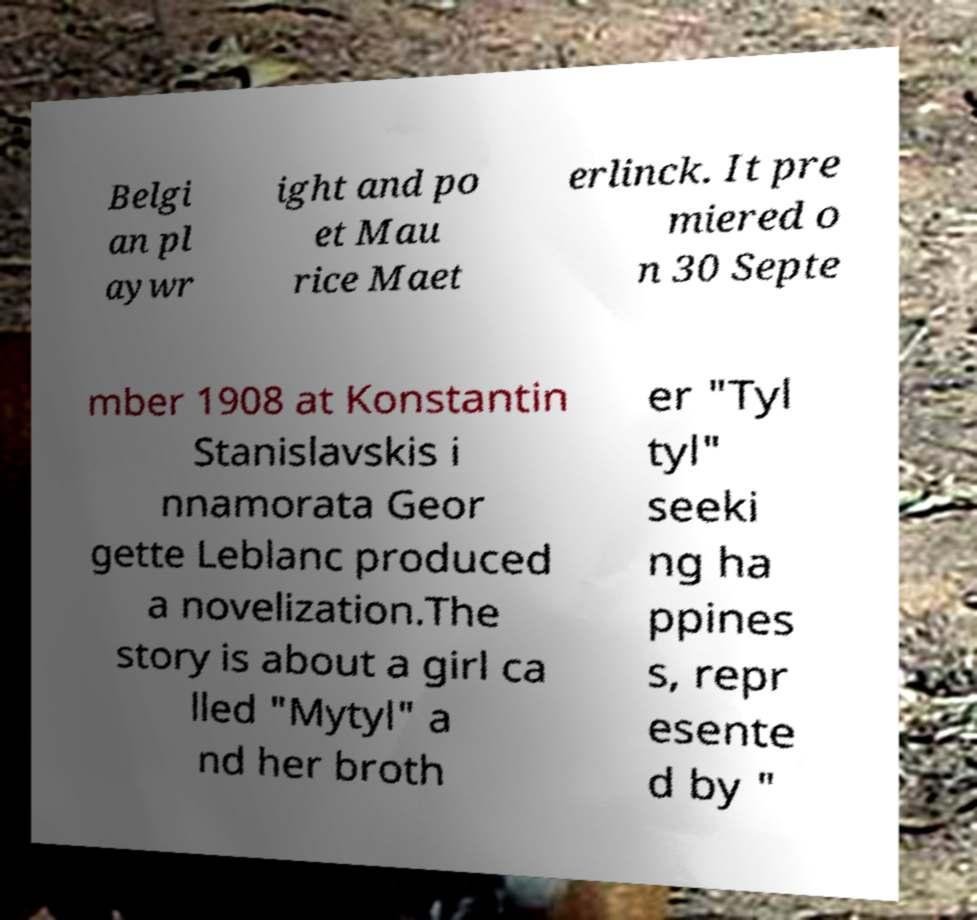There's text embedded in this image that I need extracted. Can you transcribe it verbatim? Belgi an pl aywr ight and po et Mau rice Maet erlinck. It pre miered o n 30 Septe mber 1908 at Konstantin Stanislavskis i nnamorata Geor gette Leblanc produced a novelization.The story is about a girl ca lled "Mytyl" a nd her broth er "Tyl tyl" seeki ng ha ppines s, repr esente d by " 